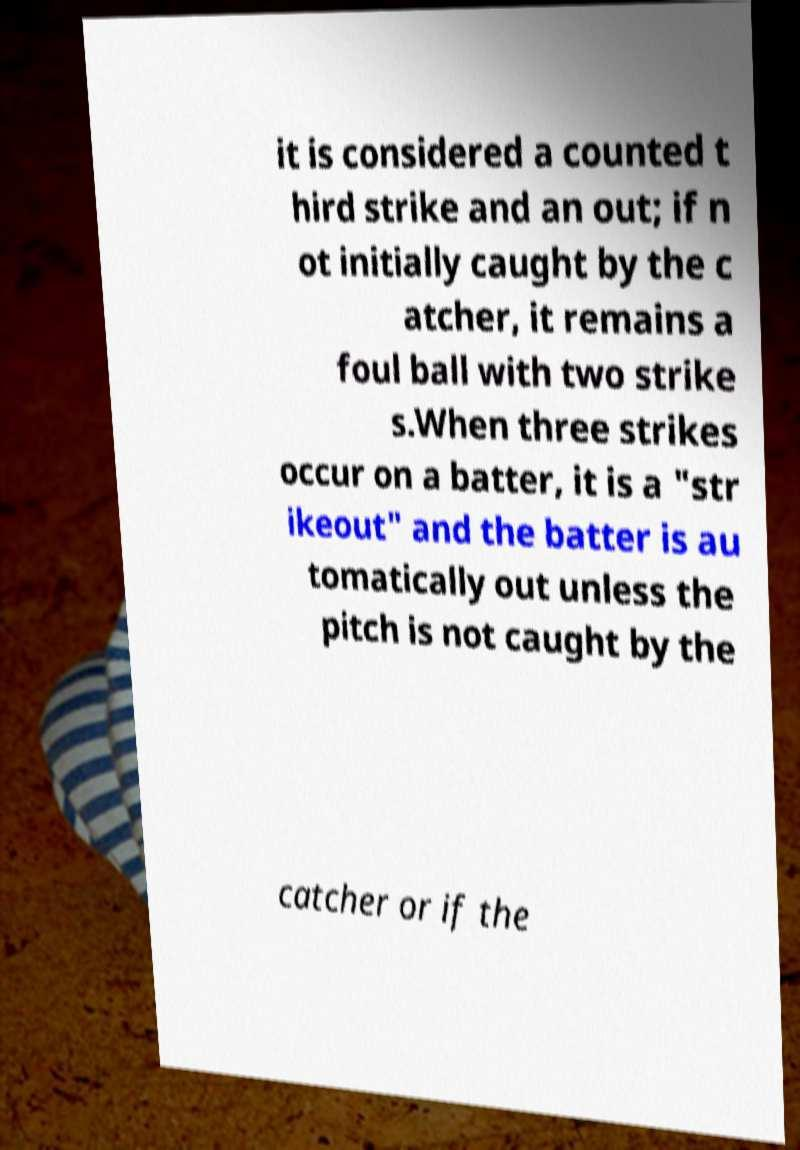There's text embedded in this image that I need extracted. Can you transcribe it verbatim? it is considered a counted t hird strike and an out; if n ot initially caught by the c atcher, it remains a foul ball with two strike s.When three strikes occur on a batter, it is a "str ikeout" and the batter is au tomatically out unless the pitch is not caught by the catcher or if the 